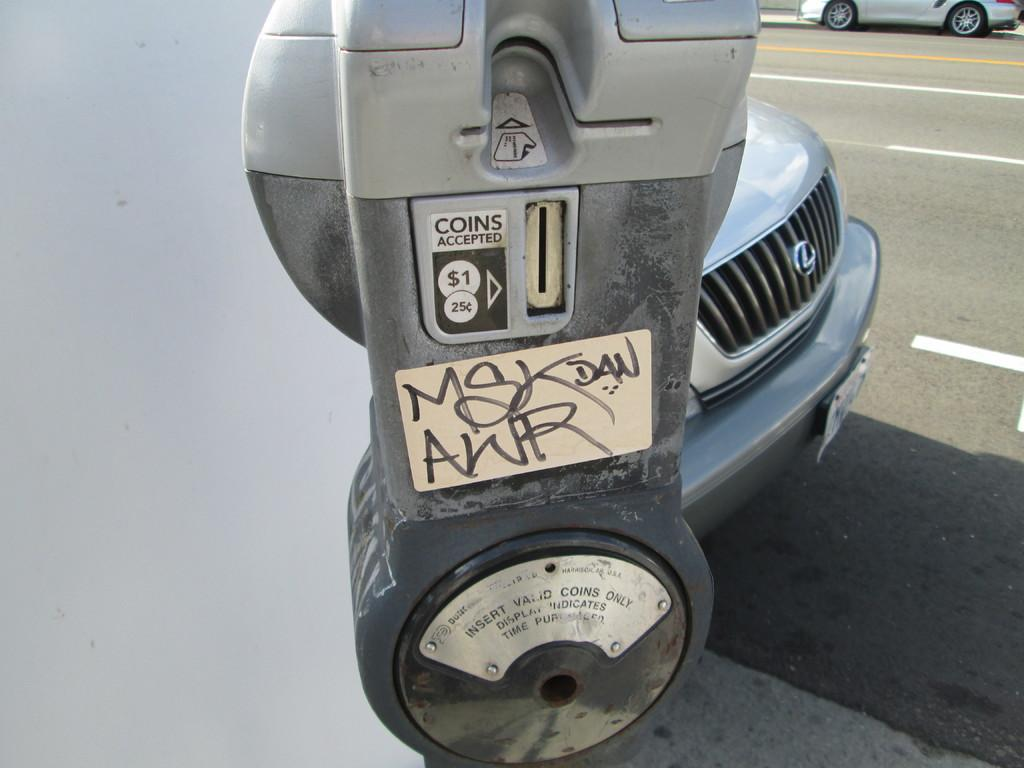<image>
Summarize the visual content of the image. A parking meter on the street next to a Lexus car that accepts $1 and 25 cent coins. 